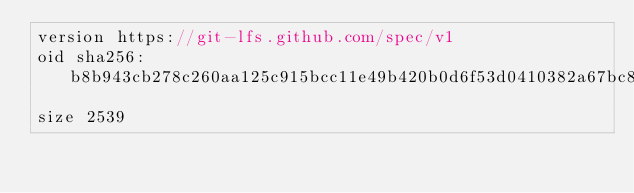Convert code to text. <code><loc_0><loc_0><loc_500><loc_500><_C++_>version https://git-lfs.github.com/spec/v1
oid sha256:b8b943cb278c260aa125c915bcc11e49b420b0d6f53d0410382a67bc88616613
size 2539
</code> 